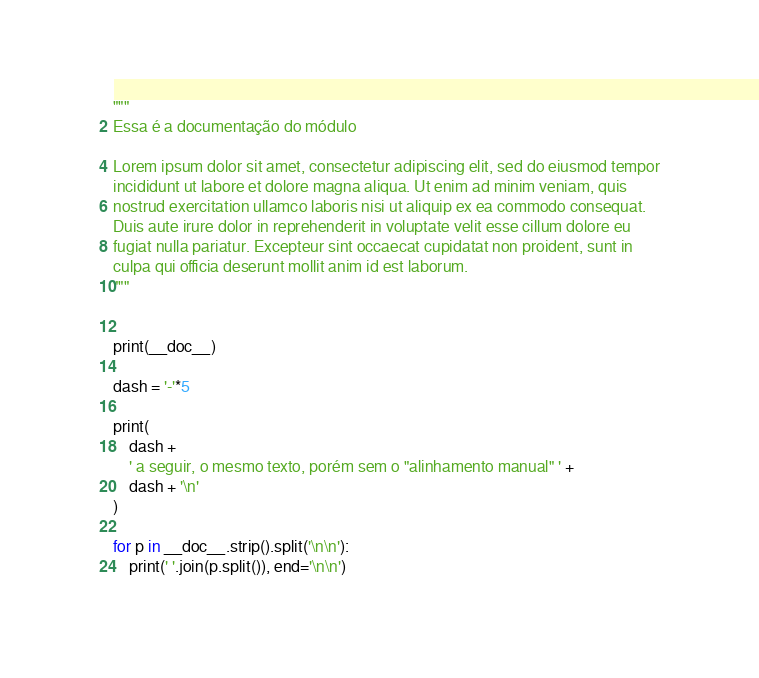<code> <loc_0><loc_0><loc_500><loc_500><_Python_>
"""
Essa é a documentação do módulo

Lorem ipsum dolor sit amet, consectetur adipiscing elit, sed do eiusmod tempor
incididunt ut labore et dolore magna aliqua. Ut enim ad minim veniam, quis
nostrud exercitation ullamco laboris nisi ut aliquip ex ea commodo consequat.
Duis aute irure dolor in reprehenderit in voluptate velit esse cillum dolore eu
fugiat nulla pariatur. Excepteur sint occaecat cupidatat non proident, sunt in
culpa qui officia deserunt mollit anim id est laborum.
"""


print(__doc__)

dash = '-'*5

print(
    dash +
    ' a seguir, o mesmo texto, porém sem o "alinhamento manual" ' +
    dash + '\n'
)

for p in __doc__.strip().split('\n\n'):
    print(' '.join(p.split()), end='\n\n')
</code> 